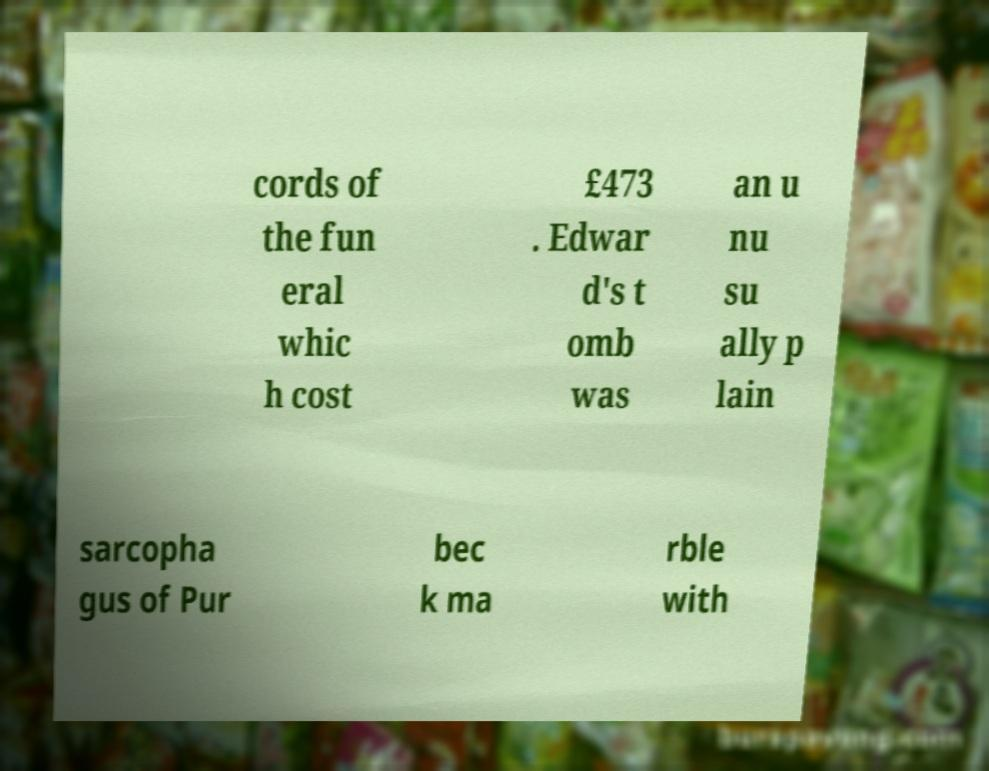I need the written content from this picture converted into text. Can you do that? cords of the fun eral whic h cost £473 . Edwar d's t omb was an u nu su ally p lain sarcopha gus of Pur bec k ma rble with 